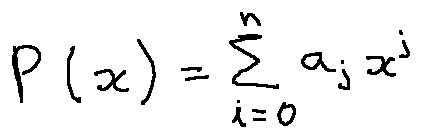<formula> <loc_0><loc_0><loc_500><loc_500>P ( x ) = \sum \lim i t s _ { i = 0 } ^ { n } a _ { j } x ^ { j }</formula> 